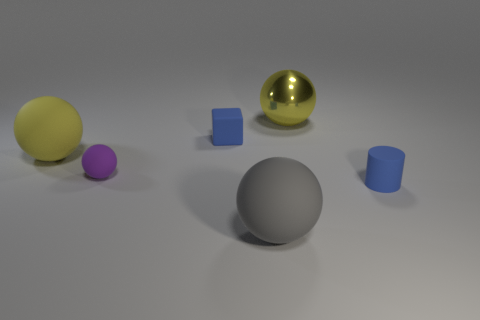There is a big gray thing that is the same shape as the purple thing; what is it made of?
Provide a succinct answer. Rubber. Is the number of small red cubes greater than the number of big metal spheres?
Give a very brief answer. No. What number of other things are there of the same color as the tiny cylinder?
Keep it short and to the point. 1. Are the gray ball and the large yellow sphere that is to the left of the small purple rubber ball made of the same material?
Your response must be concise. Yes. There is a blue object that is in front of the thing that is left of the tiny purple thing; how many gray things are behind it?
Your response must be concise. 0. Is the number of rubber cylinders in front of the metallic object less than the number of balls that are in front of the big yellow matte thing?
Give a very brief answer. Yes. How many other objects are there of the same material as the gray ball?
Offer a very short reply. 4. There is a yellow sphere that is the same size as the yellow matte object; what is it made of?
Offer a terse response. Metal. What number of gray things are either small rubber balls or large balls?
Keep it short and to the point. 1. There is a big object that is right of the yellow matte object and behind the cylinder; what is its color?
Provide a succinct answer. Yellow. 